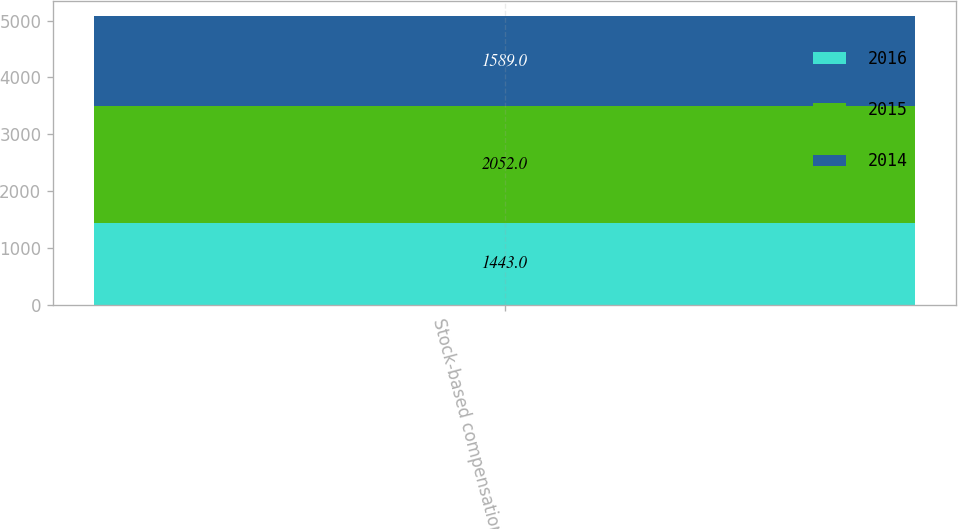Convert chart. <chart><loc_0><loc_0><loc_500><loc_500><stacked_bar_chart><ecel><fcel>Stock-based compensation<nl><fcel>2016<fcel>1443<nl><fcel>2015<fcel>2052<nl><fcel>2014<fcel>1589<nl></chart> 